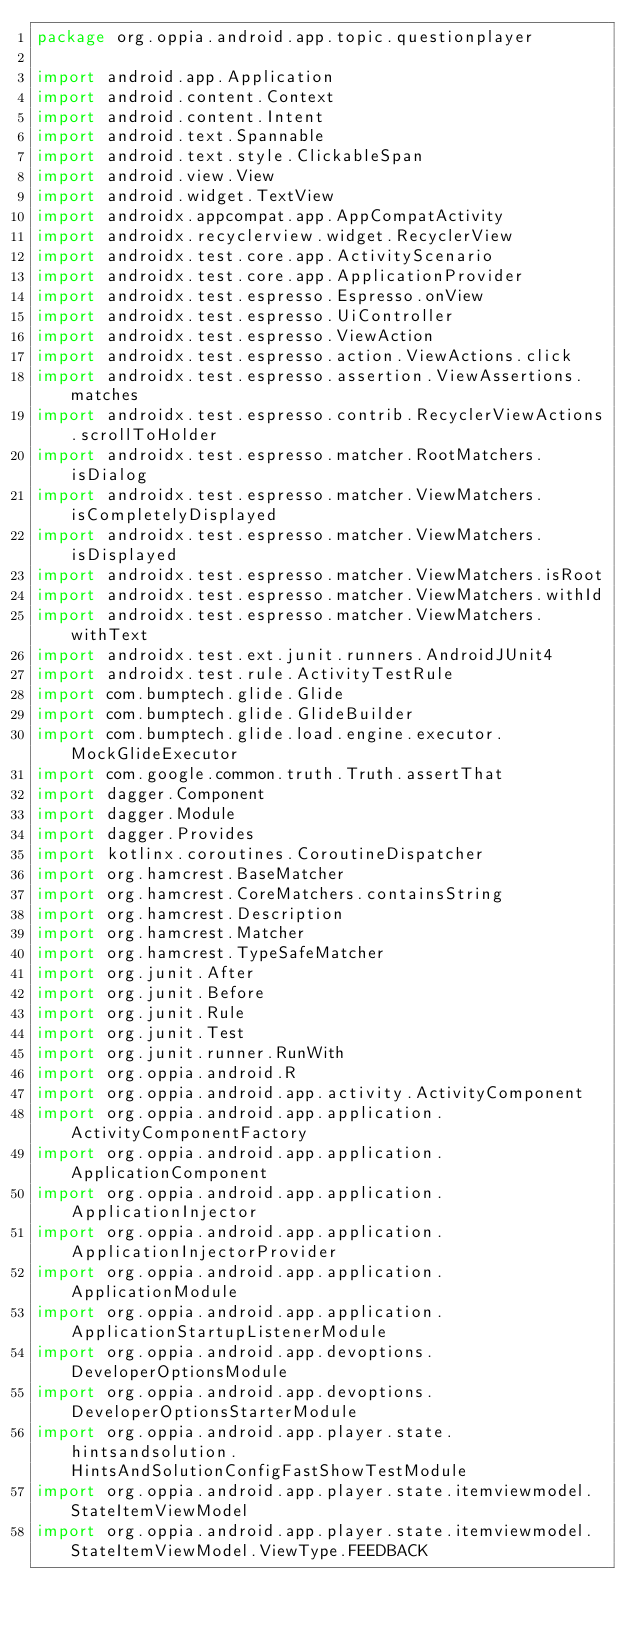Convert code to text. <code><loc_0><loc_0><loc_500><loc_500><_Kotlin_>package org.oppia.android.app.topic.questionplayer

import android.app.Application
import android.content.Context
import android.content.Intent
import android.text.Spannable
import android.text.style.ClickableSpan
import android.view.View
import android.widget.TextView
import androidx.appcompat.app.AppCompatActivity
import androidx.recyclerview.widget.RecyclerView
import androidx.test.core.app.ActivityScenario
import androidx.test.core.app.ApplicationProvider
import androidx.test.espresso.Espresso.onView
import androidx.test.espresso.UiController
import androidx.test.espresso.ViewAction
import androidx.test.espresso.action.ViewActions.click
import androidx.test.espresso.assertion.ViewAssertions.matches
import androidx.test.espresso.contrib.RecyclerViewActions.scrollToHolder
import androidx.test.espresso.matcher.RootMatchers.isDialog
import androidx.test.espresso.matcher.ViewMatchers.isCompletelyDisplayed
import androidx.test.espresso.matcher.ViewMatchers.isDisplayed
import androidx.test.espresso.matcher.ViewMatchers.isRoot
import androidx.test.espresso.matcher.ViewMatchers.withId
import androidx.test.espresso.matcher.ViewMatchers.withText
import androidx.test.ext.junit.runners.AndroidJUnit4
import androidx.test.rule.ActivityTestRule
import com.bumptech.glide.Glide
import com.bumptech.glide.GlideBuilder
import com.bumptech.glide.load.engine.executor.MockGlideExecutor
import com.google.common.truth.Truth.assertThat
import dagger.Component
import dagger.Module
import dagger.Provides
import kotlinx.coroutines.CoroutineDispatcher
import org.hamcrest.BaseMatcher
import org.hamcrest.CoreMatchers.containsString
import org.hamcrest.Description
import org.hamcrest.Matcher
import org.hamcrest.TypeSafeMatcher
import org.junit.After
import org.junit.Before
import org.junit.Rule
import org.junit.Test
import org.junit.runner.RunWith
import org.oppia.android.R
import org.oppia.android.app.activity.ActivityComponent
import org.oppia.android.app.application.ActivityComponentFactory
import org.oppia.android.app.application.ApplicationComponent
import org.oppia.android.app.application.ApplicationInjector
import org.oppia.android.app.application.ApplicationInjectorProvider
import org.oppia.android.app.application.ApplicationModule
import org.oppia.android.app.application.ApplicationStartupListenerModule
import org.oppia.android.app.devoptions.DeveloperOptionsModule
import org.oppia.android.app.devoptions.DeveloperOptionsStarterModule
import org.oppia.android.app.player.state.hintsandsolution.HintsAndSolutionConfigFastShowTestModule
import org.oppia.android.app.player.state.itemviewmodel.StateItemViewModel
import org.oppia.android.app.player.state.itemviewmodel.StateItemViewModel.ViewType.FEEDBACK</code> 